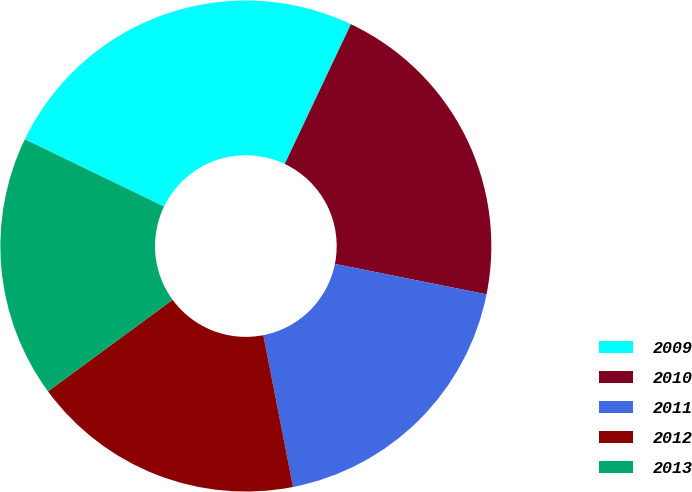<chart> <loc_0><loc_0><loc_500><loc_500><pie_chart><fcel>2009<fcel>2010<fcel>2011<fcel>2012<fcel>2013<nl><fcel>24.88%<fcel>21.11%<fcel>18.77%<fcel>18.0%<fcel>17.24%<nl></chart> 